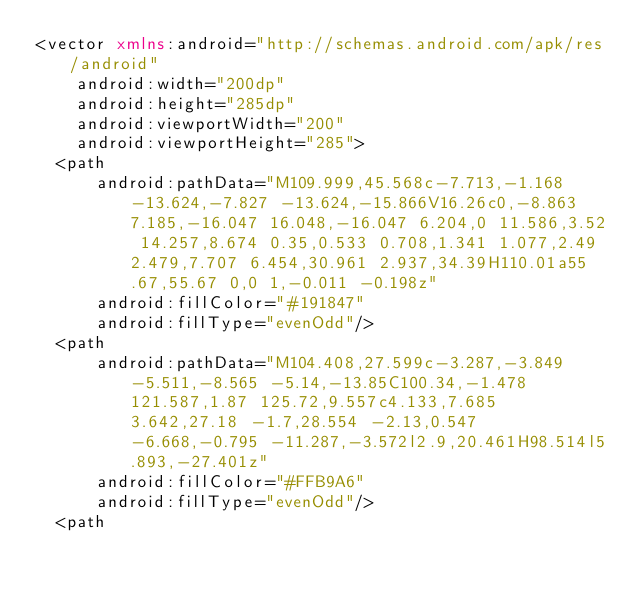Convert code to text. <code><loc_0><loc_0><loc_500><loc_500><_XML_><vector xmlns:android="http://schemas.android.com/apk/res/android"
    android:width="200dp"
    android:height="285dp"
    android:viewportWidth="200"
    android:viewportHeight="285">
  <path
      android:pathData="M109.999,45.568c-7.713,-1.168 -13.624,-7.827 -13.624,-15.866V16.26c0,-8.863 7.185,-16.047 16.048,-16.047 6.204,0 11.586,3.52 14.257,8.674 0.35,0.533 0.708,1.341 1.077,2.49 2.479,7.707 6.454,30.961 2.937,34.39H110.01a55.67,55.67 0,0 1,-0.011 -0.198z"
      android:fillColor="#191847"
      android:fillType="evenOdd"/>
  <path
      android:pathData="M104.408,27.599c-3.287,-3.849 -5.511,-8.565 -5.14,-13.85C100.34,-1.478 121.587,1.87 125.72,9.557c4.133,7.685 3.642,27.18 -1.7,28.554 -2.13,0.547 -6.668,-0.795 -11.287,-3.572l2.9,20.461H98.514l5.893,-27.401z"
      android:fillColor="#FFB9A6"
      android:fillType="evenOdd"/>
  <path</code> 